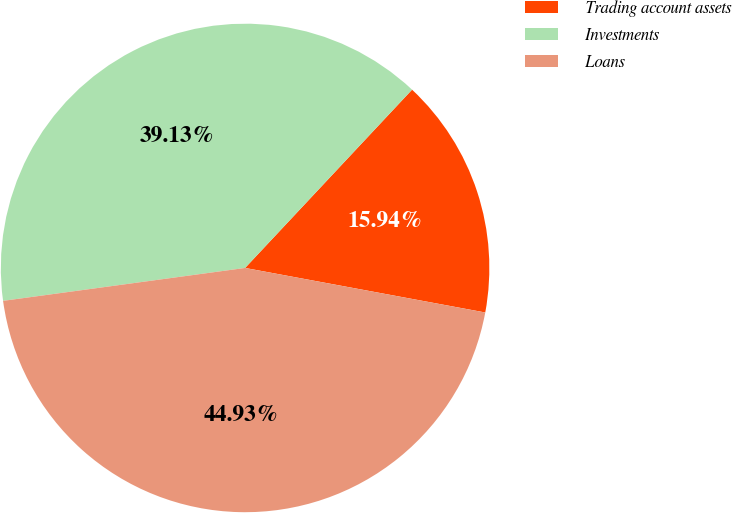Convert chart to OTSL. <chart><loc_0><loc_0><loc_500><loc_500><pie_chart><fcel>Trading account assets<fcel>Investments<fcel>Loans<nl><fcel>15.94%<fcel>39.13%<fcel>44.93%<nl></chart> 